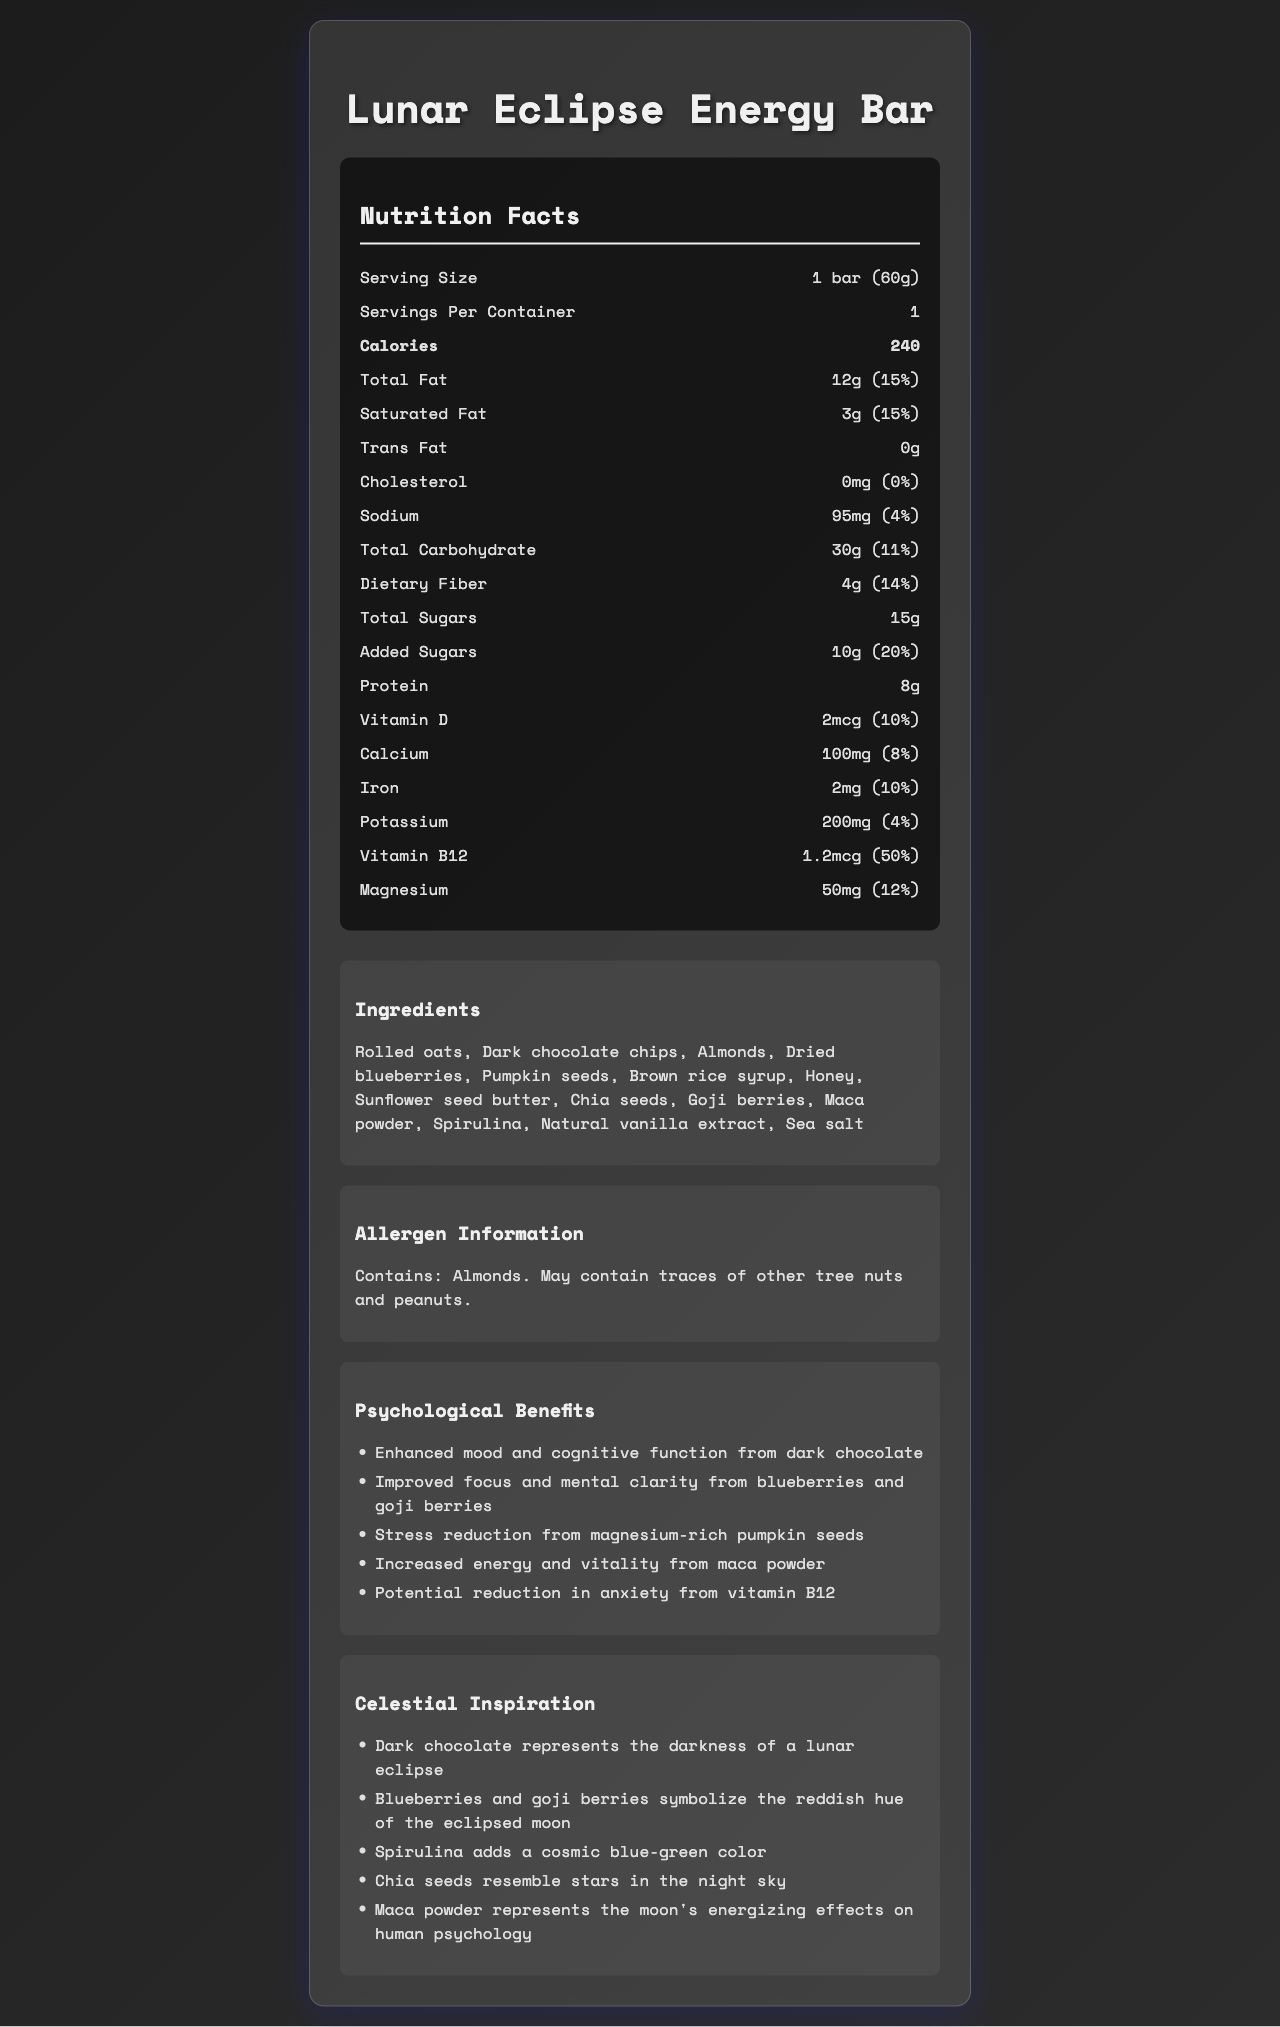what is the serving size? The serving size is listed as "1 bar (60g)" in the nutrition label section of the document.
Answer: 1 bar (60g) how many calories are in one serving? The document lists 240 calories per serving.
Answer: 240 what is the total fat content per serving and its daily value percentage? The document states that total fat per serving is 12g, which constitutes 15% of the daily value.
Answer: 12g (15%) what are the psychological benefits mentioned for blueberries and goji berries? The document lists psychological benefits and specifies "Improved focus and mental clarity from blueberries and goji berries."
Answer: Improved focus and mental clarity how much sodium does one bar contain? The sodium content per serving is listed as 95mg.
Answer: 95mg what are the celestial-inspired ingredients mentioned in the document? A. Almonds and goji berries B. Blueberries and spirulina C. Chia seeds and honey D. Sea salt and pumpkin seeds The celestial-inspired ingredients mentioned include dark chocolate, blueberries, goji berries, spirulina, chia seeds, and maca powder.
Answer: B how many grams of protein does a Lunar Eclipse Energy Bar contain? A. 5g B. 8g C. 10g D. 12g The document lists the protein content as 8g per serving.
Answer: B is the Lunar Eclipse Energy Bar suitable for someone allergic to tree nuts? Yes/No The allergen information indicates that the bar contains almonds and may contain traces of other tree nuts and peanuts.
Answer: No how does the Lunar Eclipse Energy Bar represent the darkness of a lunar eclipse? The celestial inspiration section of the document states that dark chocolate represents the darkness of a lunar eclipse.
Answer: Dark chocolate summarize the main purpose of the document. This summary captures the primary purpose of the document, which is to inform consumers about the nutritional content, ingredients, potential allergens, psychological benefits, and the celestial theme of the product.
Answer: The document provides detailed nutritional information, ingredients, allergen information, psychological benefits, and celestial inspiration for the Lunar Eclipse Energy Bar. what is the primary source of added sugars in the Lunar Eclipse Energy Bar? The document lists the amount of added sugars but does not specify the primary source of those added sugars.
Answer: Cannot be determined 